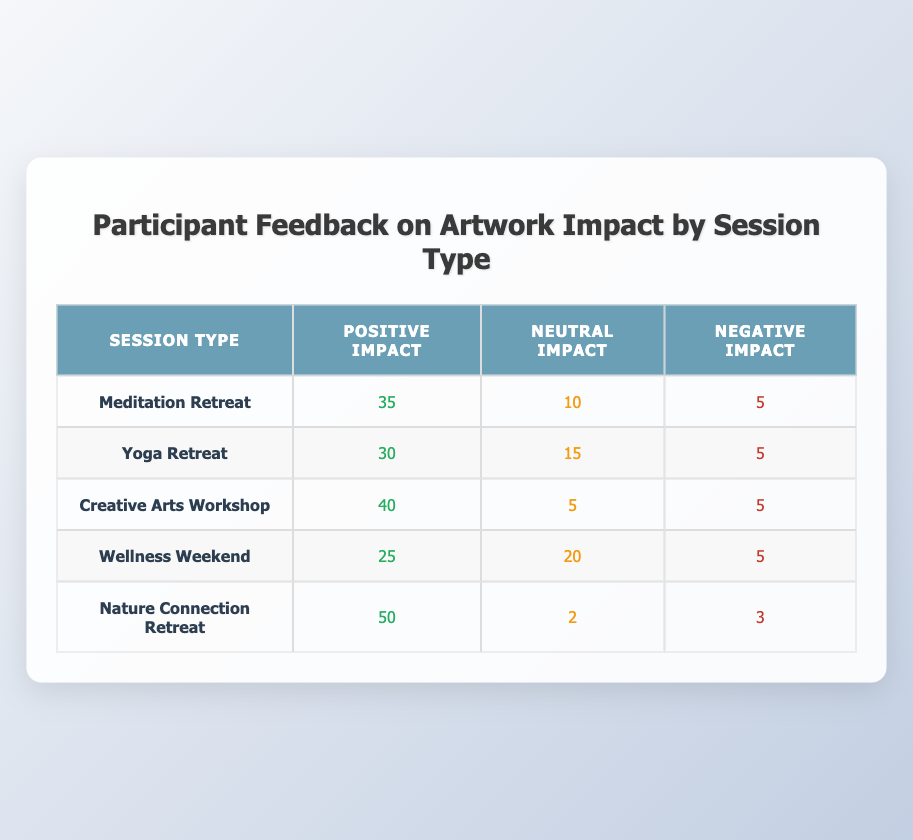What is the total number of participants who felt a positive impact from the artwork in the Meditation Retreat? According to the table, the number of participants who felt a positive impact from the artwork in the Meditation Retreat is 35.
Answer: 35 How many participants experienced a neutral impact during the Yoga Retreat? From the table, it shows that 15 participants experienced a neutral impact during the Yoga Retreat.
Answer: 15 What is the combined total of negative feedback across all retreat sessions? To calculate this, we add the negative impact values from each session: 5 (Meditation) + 5 (Yoga) + 5 (Creative Arts) + 5 (Wellness) + 3 (Nature) = 23.
Answer: 23 Which session type had the highest number of participants reporting a positive impact? By examining the table, we find that the Nature Connection Retreat had the highest positive impact with 50 participants.
Answer: Nature Connection Retreat Is it true that the Creative Arts Workshop had more participants reporting negative impact than the Wellness Weekend? The Creative Arts Workshop had 5 negative responses, while the Wellness Weekend also had 5 negative responses. So the statement is false; they are equal.
Answer: No What is the average number of participants who reported a neutral impact across all sessions? First, we sum the neutral impact values: 10 (Meditation) + 15 (Yoga) + 5 (Creative Arts) + 20 (Wellness) + 2 (Nature) = 52. Then, we divide that by the number of sessions (5), which gives us an average of 52/5 = 10.4.
Answer: 10.4 Which session type had the lowest overall positive impact? The data shows the positive impacts as follows: Meditation Retreat (35), Yoga Retreat (30), Creative Arts Workshop (40), Wellness Weekend (25), and Nature Connection Retreat (50). The lowest is the Wellness Weekend with 25.
Answer: Wellness Weekend How many total participants reported a positive impact across all sessions? We add the positive impact figures from each session: 35 (Meditation) + 30 (Yoga) + 40 (Creative Arts) + 25 (Wellness) + 50 (Nature) = 180.
Answer: 180 Is it correct to say that more participants reported a positive impact than those who reported a neutral impact across all sessions? Total positive impacts: 180. Total neutral impacts: 52. Since 180 is greater than 52, the statement is true.
Answer: Yes 